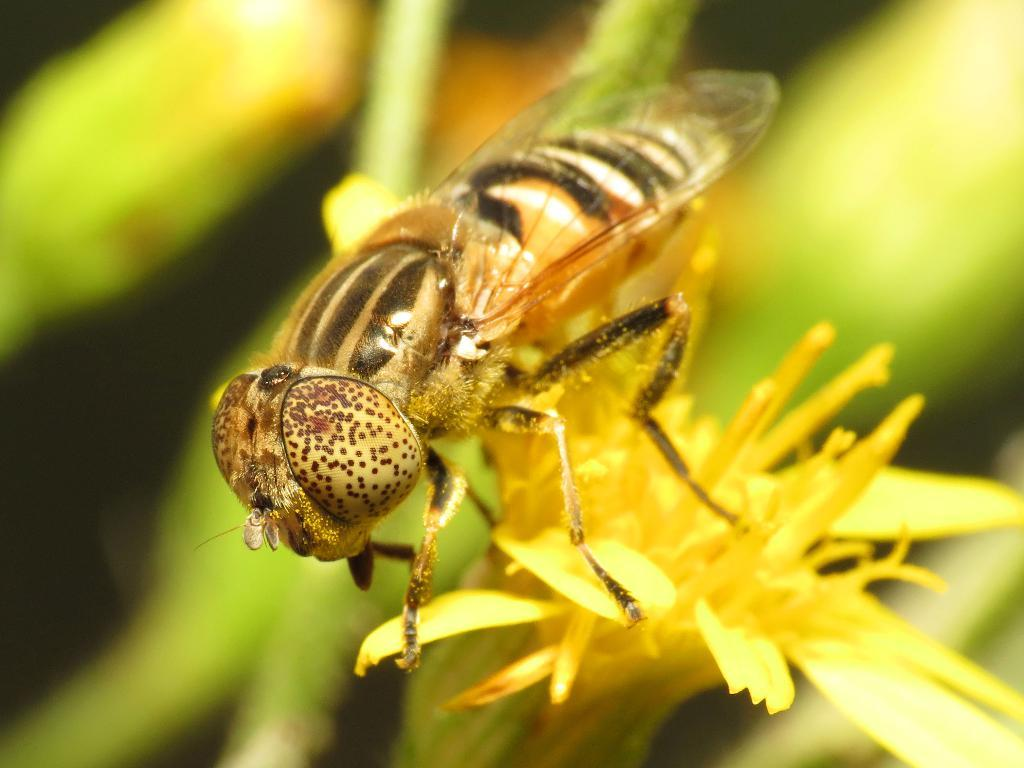What is the main subject of the image? There is a bee in the image. What is the bee standing on? The bee is standing on a yellow flower. Can you describe the background of the image? The background of the image is blurred. How many bikes are visible in the image? There are no bikes present in the image; it features a bee standing on a yellow flower with a blurred background. 